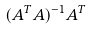Convert formula to latex. <formula><loc_0><loc_0><loc_500><loc_500>( A ^ { T } A ) ^ { - 1 } A ^ { T }</formula> 